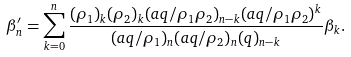<formula> <loc_0><loc_0><loc_500><loc_500>\beta ^ { \prime } _ { n } = \sum _ { k = 0 } ^ { n } \frac { ( \rho _ { 1 } ) _ { k } ( \rho _ { 2 } ) _ { k } ( a q / \rho _ { 1 } \rho _ { 2 } ) _ { n - k } ( a q / \rho _ { 1 } \rho _ { 2 } ) ^ { k } } { ( a q / \rho _ { 1 } ) _ { n } ( a q / \rho _ { 2 } ) _ { n } ( q ) _ { n - k } } \beta _ { k } .</formula> 